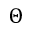<formula> <loc_0><loc_0><loc_500><loc_500>\Theta</formula> 